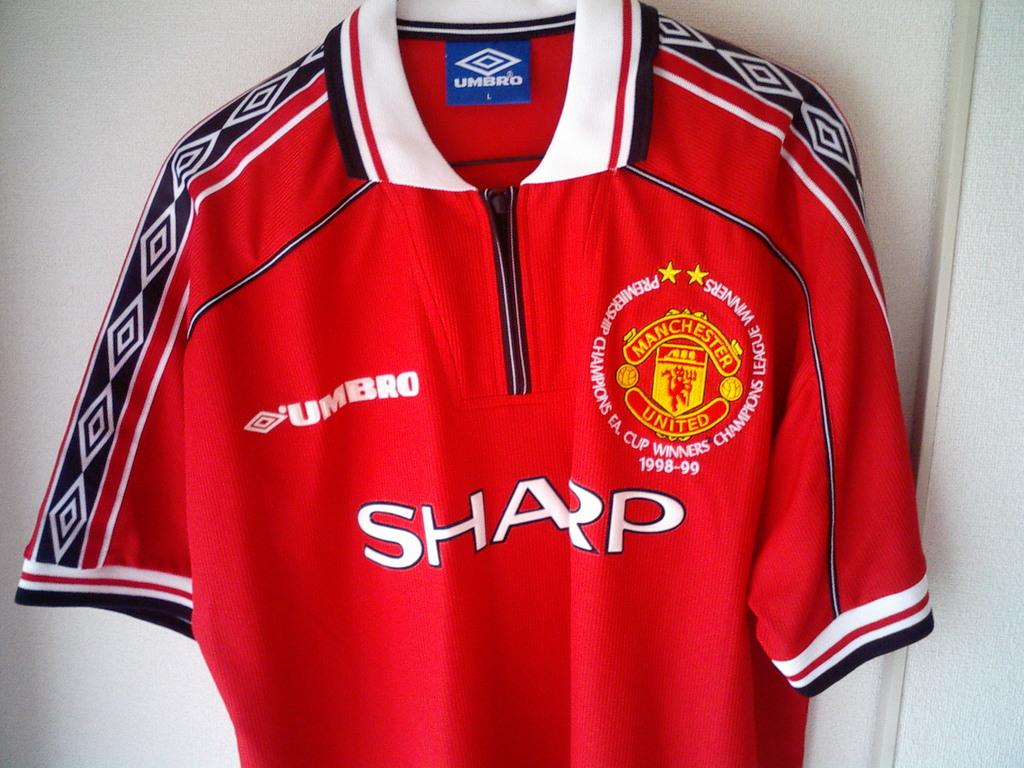<image>
Render a clear and concise summary of the photo. A jersey has an Umbro logo on the front of it. 